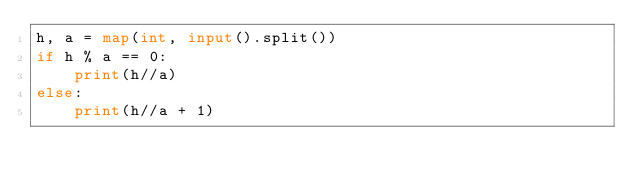<code> <loc_0><loc_0><loc_500><loc_500><_Python_>h, a = map(int, input().split())
if h % a == 0:
    print(h//a)
else:
    print(h//a + 1)</code> 